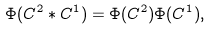<formula> <loc_0><loc_0><loc_500><loc_500>\Phi ( C ^ { 2 } * C ^ { 1 } ) = \Phi ( C ^ { 2 } ) \Phi ( C ^ { 1 } ) ,</formula> 